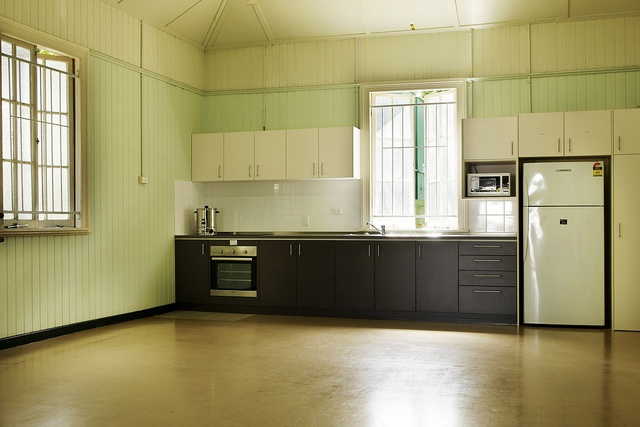Describe the objects in this image and their specific colors. I can see refrigerator in olive, tan, and lightgray tones, oven in olive and black tones, microwave in olive, black, darkgray, lightgray, and gray tones, sink in olive, black, gray, darkgray, and darkgreen tones, and sink in olive, gray, lightgray, and black tones in this image. 